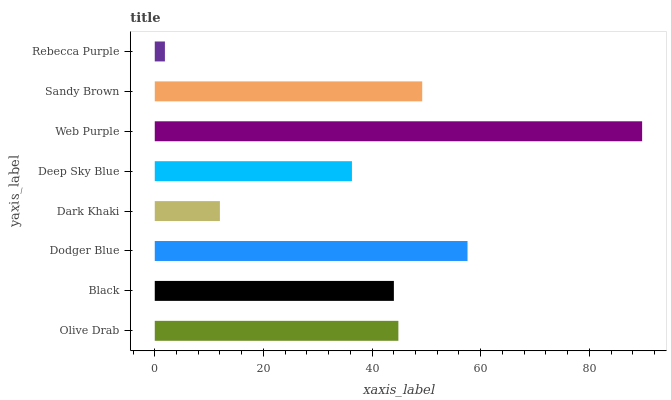Is Rebecca Purple the minimum?
Answer yes or no. Yes. Is Web Purple the maximum?
Answer yes or no. Yes. Is Black the minimum?
Answer yes or no. No. Is Black the maximum?
Answer yes or no. No. Is Olive Drab greater than Black?
Answer yes or no. Yes. Is Black less than Olive Drab?
Answer yes or no. Yes. Is Black greater than Olive Drab?
Answer yes or no. No. Is Olive Drab less than Black?
Answer yes or no. No. Is Olive Drab the high median?
Answer yes or no. Yes. Is Black the low median?
Answer yes or no. Yes. Is Web Purple the high median?
Answer yes or no. No. Is Rebecca Purple the low median?
Answer yes or no. No. 